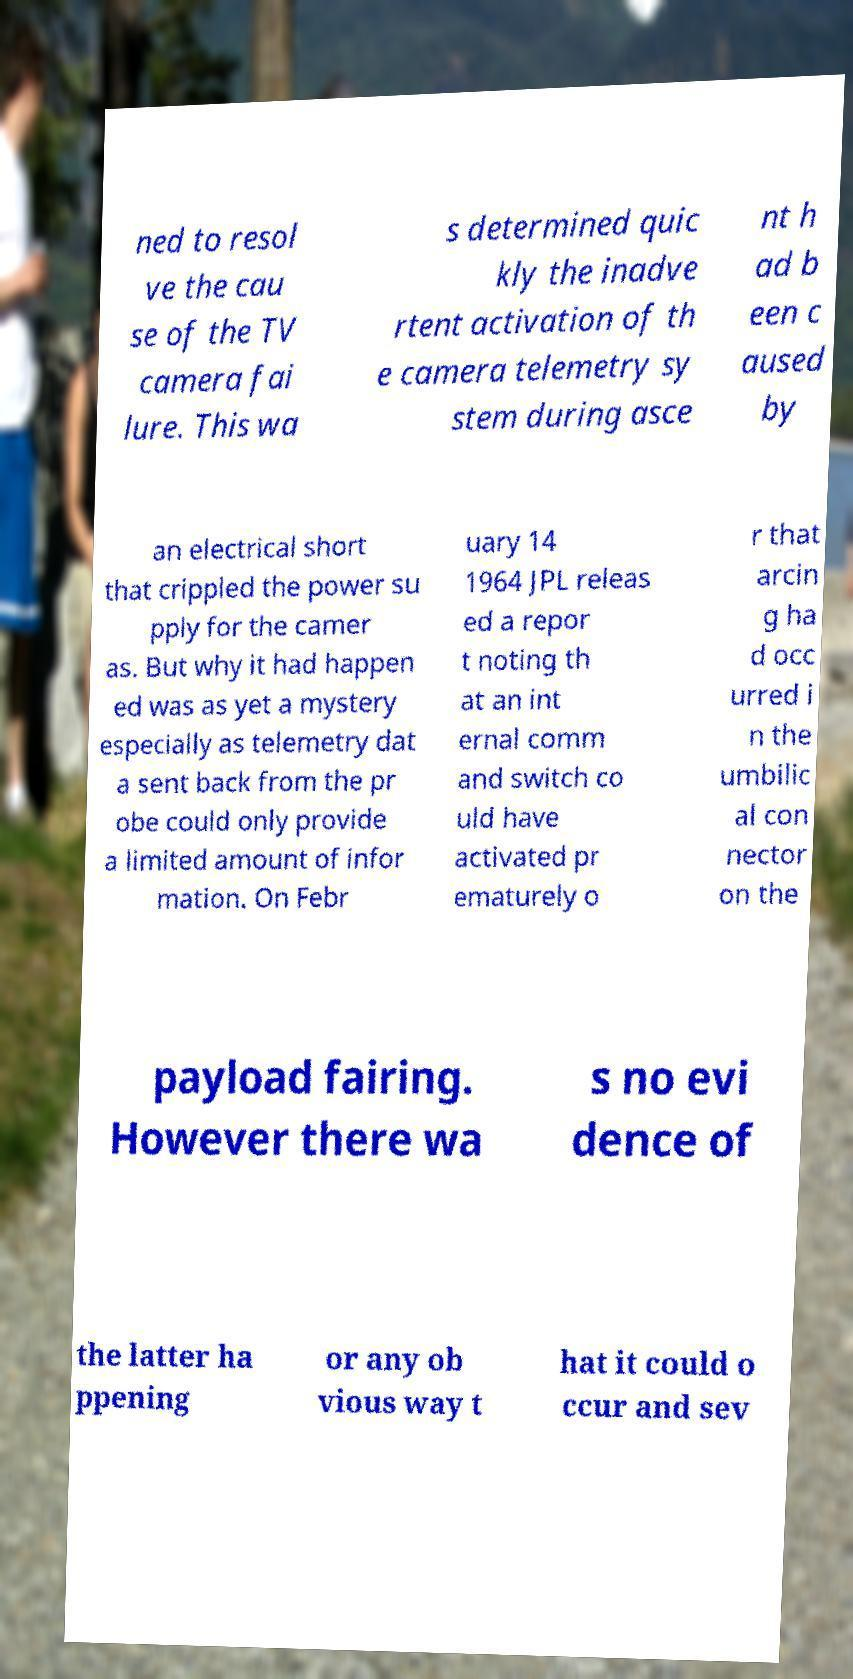For documentation purposes, I need the text within this image transcribed. Could you provide that? ned to resol ve the cau se of the TV camera fai lure. This wa s determined quic kly the inadve rtent activation of th e camera telemetry sy stem during asce nt h ad b een c aused by an electrical short that crippled the power su pply for the camer as. But why it had happen ed was as yet a mystery especially as telemetry dat a sent back from the pr obe could only provide a limited amount of infor mation. On Febr uary 14 1964 JPL releas ed a repor t noting th at an int ernal comm and switch co uld have activated pr ematurely o r that arcin g ha d occ urred i n the umbilic al con nector on the payload fairing. However there wa s no evi dence of the latter ha ppening or any ob vious way t hat it could o ccur and sev 